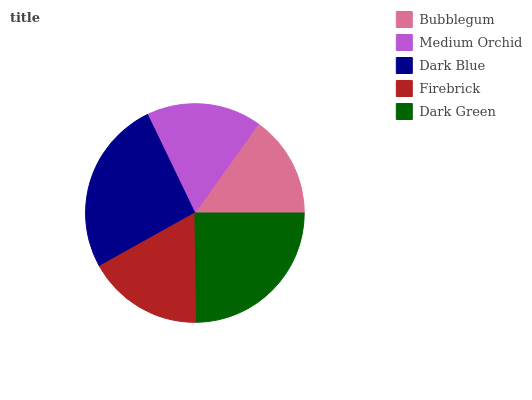Is Bubblegum the minimum?
Answer yes or no. Yes. Is Dark Blue the maximum?
Answer yes or no. Yes. Is Medium Orchid the minimum?
Answer yes or no. No. Is Medium Orchid the maximum?
Answer yes or no. No. Is Medium Orchid greater than Bubblegum?
Answer yes or no. Yes. Is Bubblegum less than Medium Orchid?
Answer yes or no. Yes. Is Bubblegum greater than Medium Orchid?
Answer yes or no. No. Is Medium Orchid less than Bubblegum?
Answer yes or no. No. Is Firebrick the high median?
Answer yes or no. Yes. Is Firebrick the low median?
Answer yes or no. Yes. Is Dark Blue the high median?
Answer yes or no. No. Is Dark Green the low median?
Answer yes or no. No. 